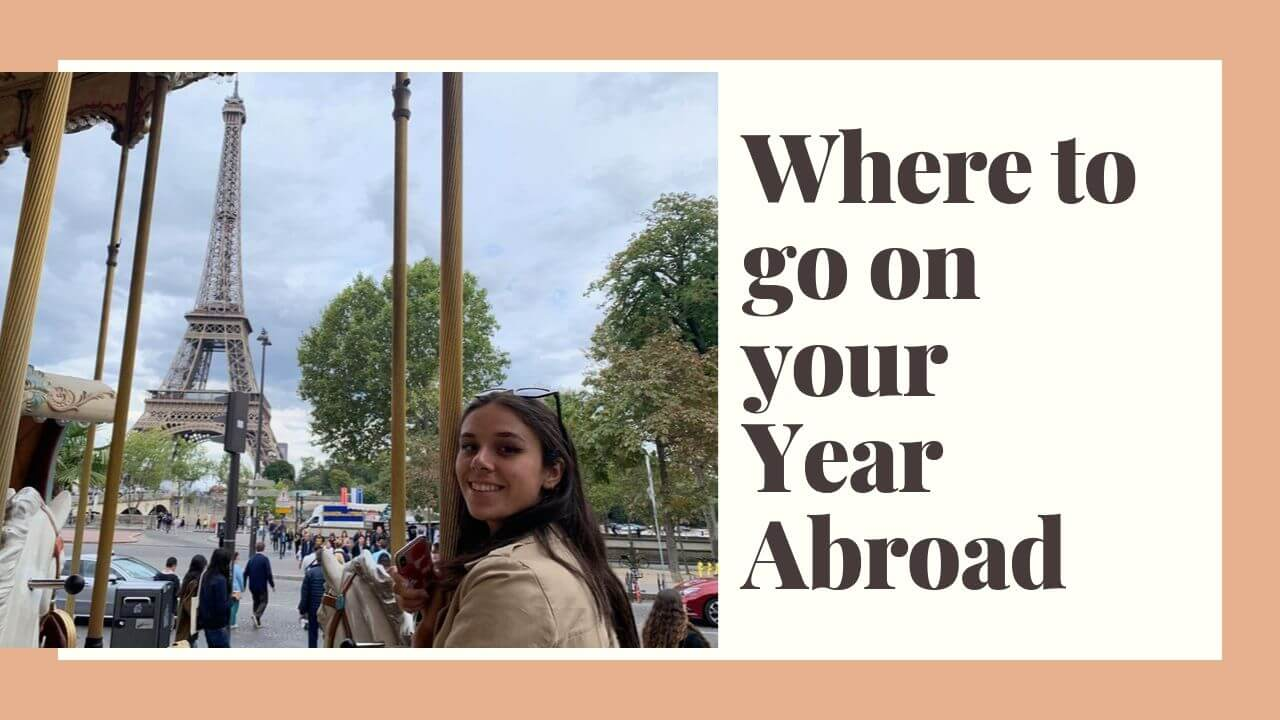Imagine a brief interaction between the woman in the image and a local Parisian she meets by the carousel. The woman turns and notices an elderly Parisian woman admiring the carousel. 'Bonjour!' she greets with a smile. 'Bonjour!' the Parisian responds warmly. They chat about the best local cafes, hidden gems in the city, and the importance of savoring every moment. The Parisian woman shares stories from her youth, offering rich history and a sense of connection as they both enjoy the magical ambiance of Paris. 